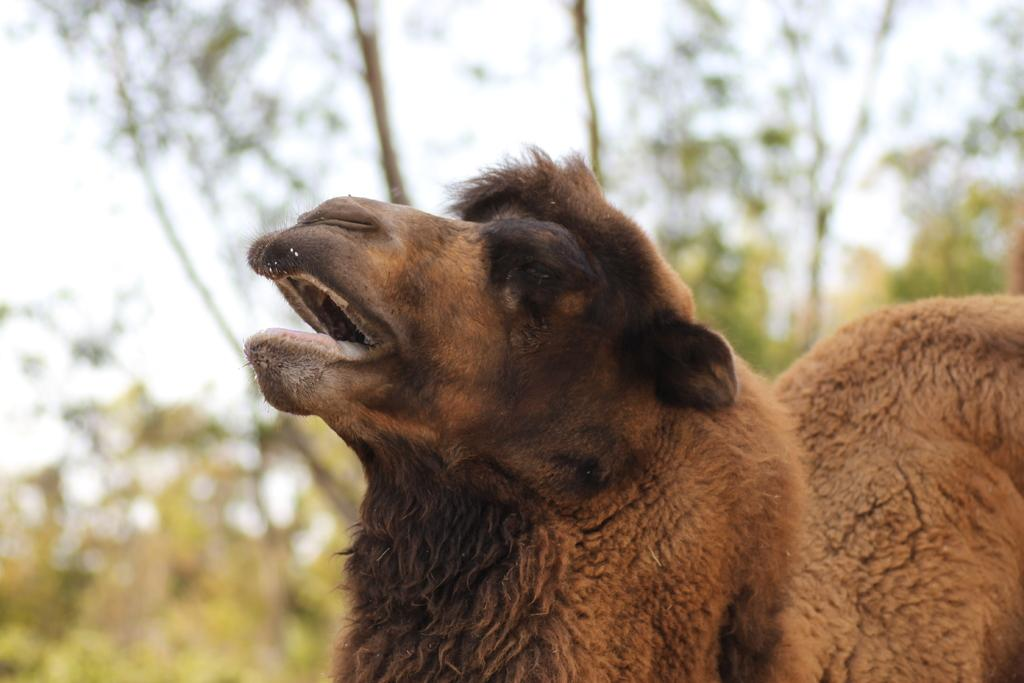What animals are in the front of the image? There are sheeps in the front of the image. What type of vegetation can be seen in the background of the image? There are trees in the background of the image. How would you describe the appearance of the background in the image? The background of the image is blurred. Can you see any airplanes flying over the cemetery in the image? There is no cemetery or airplane present in the image. 